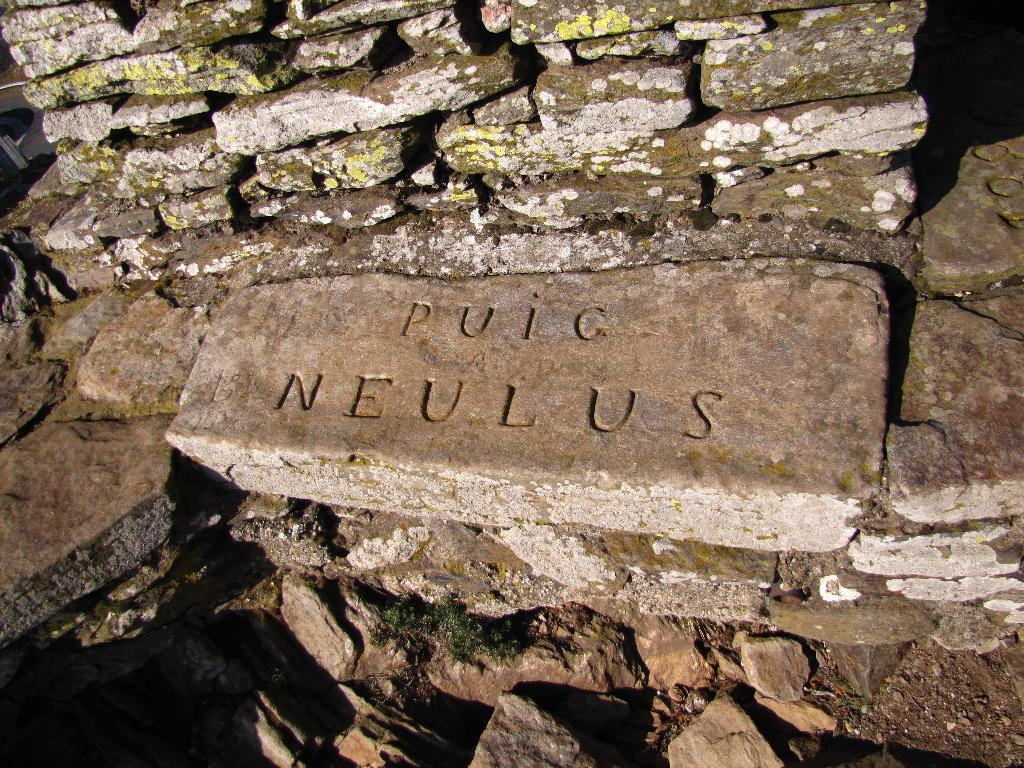What type of objects can be seen in the image? There are stones in the image. Can you describe any additional features of the stones? Something is written on at least one of the stones. What type of work does the manager do in the image? There is no manager or work-related activity depicted in the image; it only features stones with writing on them. 